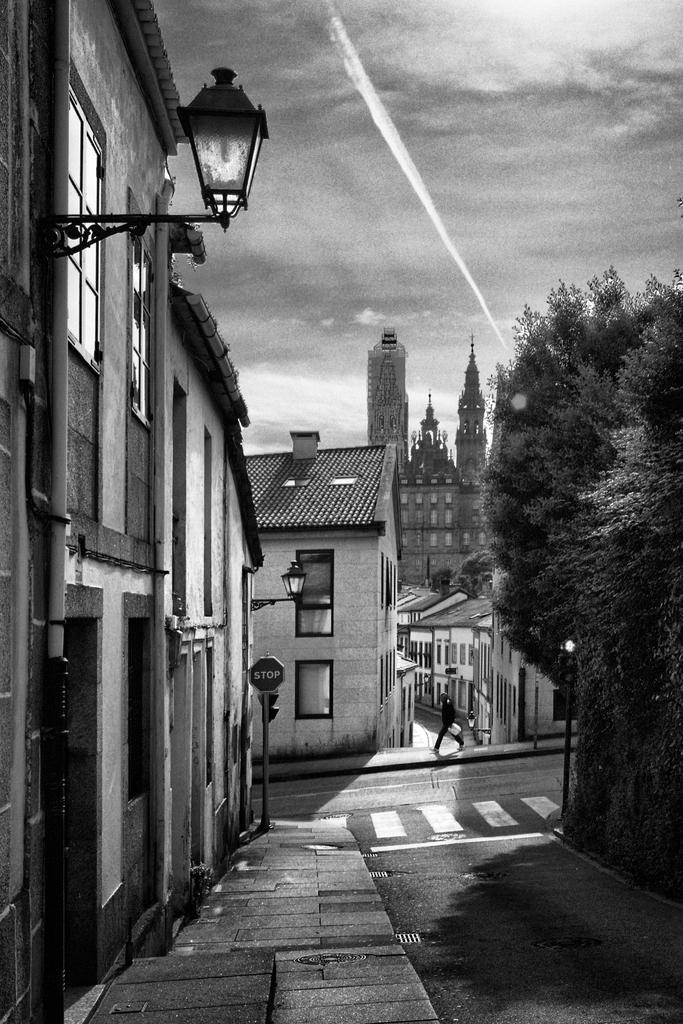Describe this image in one or two sentences. In this image I can see number of buildings, few lights, a tree, few moles, a sign board and here I can see few lines on road. I can also see this image is black and white in colour. 